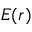Convert formula to latex. <formula><loc_0><loc_0><loc_500><loc_500>E ( r )</formula> 